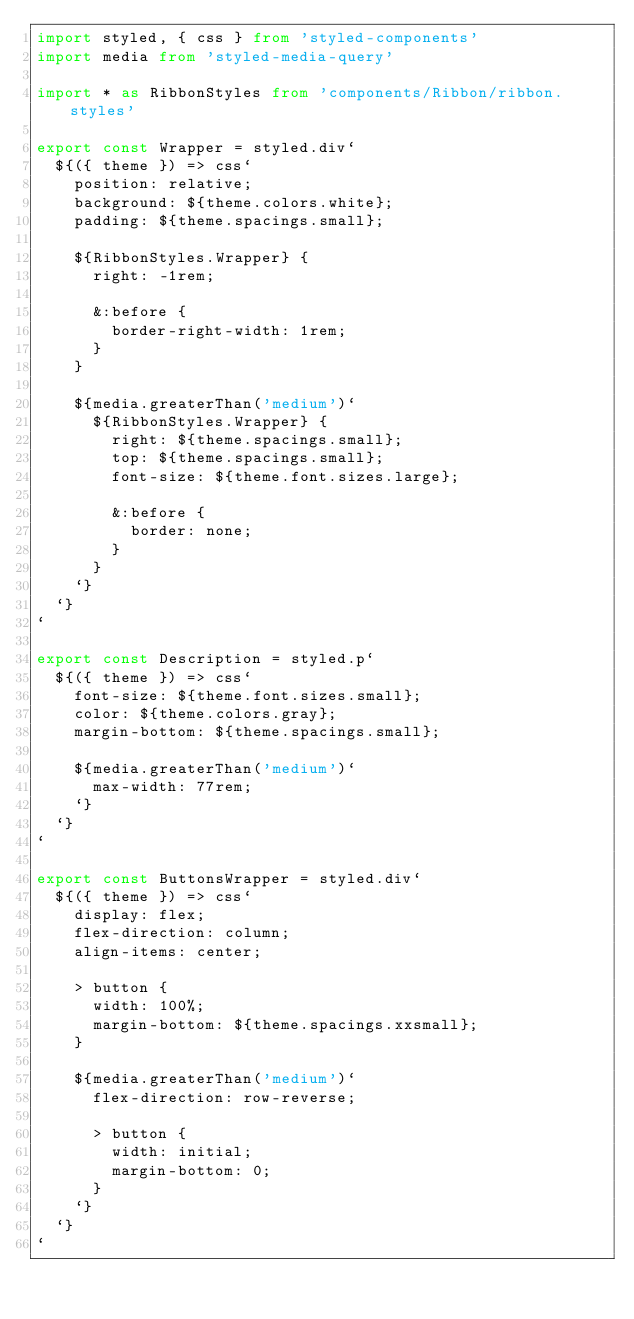Convert code to text. <code><loc_0><loc_0><loc_500><loc_500><_TypeScript_>import styled, { css } from 'styled-components'
import media from 'styled-media-query'

import * as RibbonStyles from 'components/Ribbon/ribbon.styles'

export const Wrapper = styled.div`
  ${({ theme }) => css`
    position: relative;
    background: ${theme.colors.white};
    padding: ${theme.spacings.small};

    ${RibbonStyles.Wrapper} {
      right: -1rem;

      &:before {
        border-right-width: 1rem;
      }
    }

    ${media.greaterThan('medium')`
      ${RibbonStyles.Wrapper} {
        right: ${theme.spacings.small};
        top: ${theme.spacings.small};
        font-size: ${theme.font.sizes.large};

        &:before {
          border: none;
        }
      }
    `}
  `}
`

export const Description = styled.p`
  ${({ theme }) => css`
    font-size: ${theme.font.sizes.small};
    color: ${theme.colors.gray};
    margin-bottom: ${theme.spacings.small};

    ${media.greaterThan('medium')`
      max-width: 77rem;
    `}
  `}
`

export const ButtonsWrapper = styled.div`
  ${({ theme }) => css`
    display: flex;
    flex-direction: column;
    align-items: center;

    > button {
      width: 100%;
      margin-bottom: ${theme.spacings.xxsmall};
    }

    ${media.greaterThan('medium')`
      flex-direction: row-reverse;

      > button {
        width: initial;
        margin-bottom: 0;
      }
    `}
  `}
`
</code> 